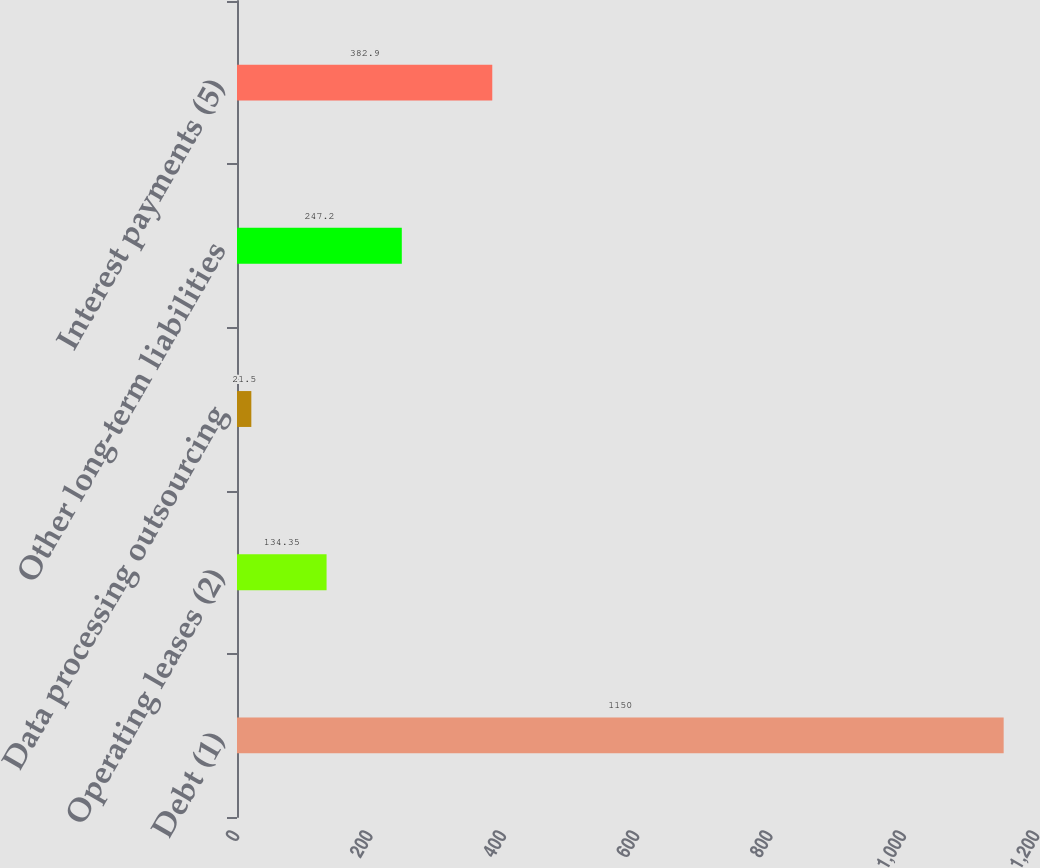Convert chart. <chart><loc_0><loc_0><loc_500><loc_500><bar_chart><fcel>Debt (1)<fcel>Operating leases (2)<fcel>Data processing outsourcing<fcel>Other long-term liabilities<fcel>Interest payments (5)<nl><fcel>1150<fcel>134.35<fcel>21.5<fcel>247.2<fcel>382.9<nl></chart> 